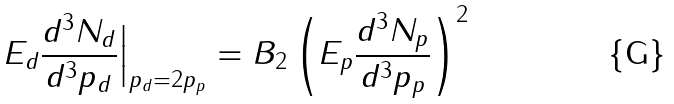Convert formula to latex. <formula><loc_0><loc_0><loc_500><loc_500>E _ { d } \frac { d ^ { 3 } N _ { d } } { d ^ { 3 } p _ { d } } \Big | _ { p _ { d } = 2 p _ { p } } = B _ { 2 } \left ( E _ { p } \frac { d ^ { 3 } N _ { p } } { d ^ { 3 } p _ { p } } \right ) ^ { 2 }</formula> 